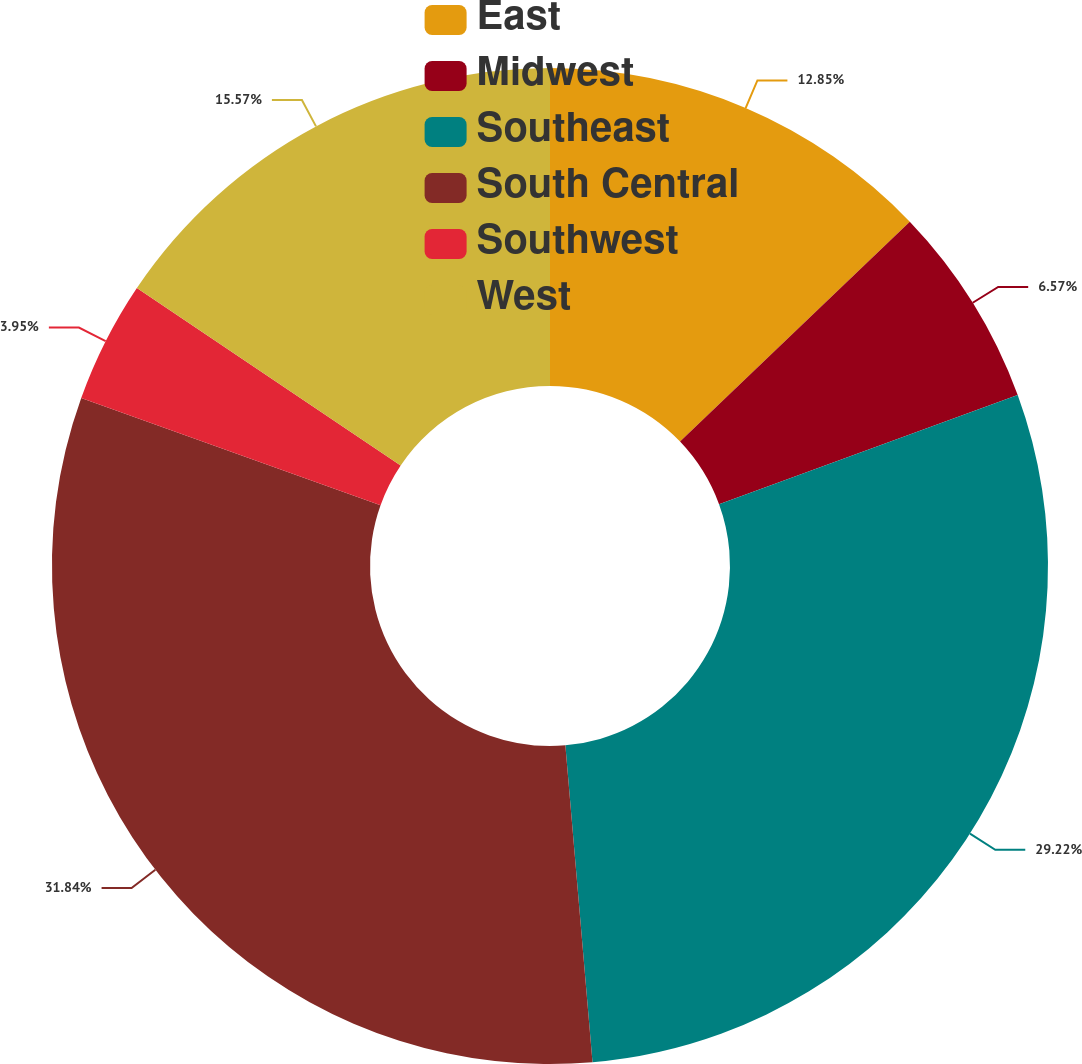Convert chart to OTSL. <chart><loc_0><loc_0><loc_500><loc_500><pie_chart><fcel>East<fcel>Midwest<fcel>Southeast<fcel>South Central<fcel>Southwest<fcel>West<nl><fcel>12.85%<fcel>6.57%<fcel>29.22%<fcel>31.84%<fcel>3.95%<fcel>15.57%<nl></chart> 